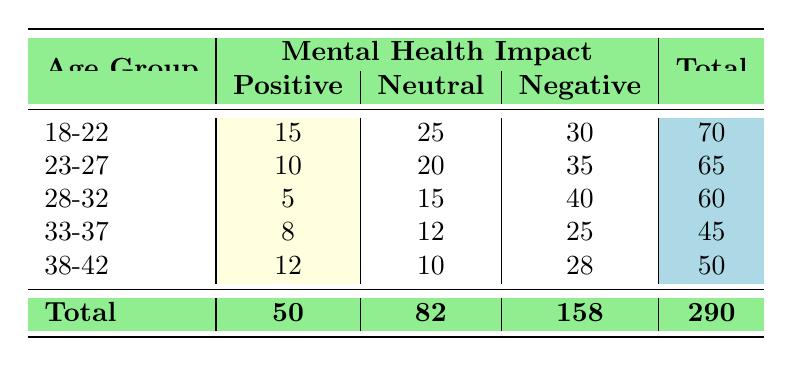What is the total number of students in the age group 18-22? From the table, the total number of students in the age group 18-22 is indicated in the last column of that row. It shows a total of 70 students.
Answer: 70 How many students reported a negative impact on mental health in the age group 23-27? In the row for the age group 23-27, the "Negative" column shows 35 students reported a negative impact.
Answer: 35 Which age group had the highest number of positive mental health impacts? By comparing the "Positive" values across all age groups, the age group 18-22 has the highest count at 15, while others have lower values.
Answer: 18-22 What is the total number of students who reported a neutral impact on their mental health across all age groups? To find this, we sum the values in the "Neutral" column: 25 (18-22) + 20 (23-27) + 15 (28-32) + 12 (33-37) + 10 (38-42) = 82.
Answer: 82 Is it true that all age groups have more students reporting a negative impact than a positive impact? By examining the data, we see that for each age group, the number of students reporting a negative impact is greater than the number reporting a positive impact. Therefore, the statement is true.
Answer: Yes Which age group has the lowest total number of students? The total number of students for each age group is given in the last column. The age group 33-37 has the lowest total of 45 students compared to the others.
Answer: 33-37 What is the difference between the total number of students reporting positive and negative impacts across all age groups? The total number of students reporting positive impacts is 50, and those reporting negative impacts is 158. The difference is calculated as 158 - 50 = 108.
Answer: 108 What percentage of the students in the age group 28-32 had a neutral impact on their mental health? For age group 28-32, 15 students reported a neutral impact out of a total of 60 students. Therefore, the percentage is (15/60) * 100 = 25%.
Answer: 25% In the age group 38-42, was the number of neutral responses greater than the number of positive responses? In this age group, there are 10 neutral responses and 12 positive responses. The number of neutral responses is not greater than the number of positive responses.
Answer: No 